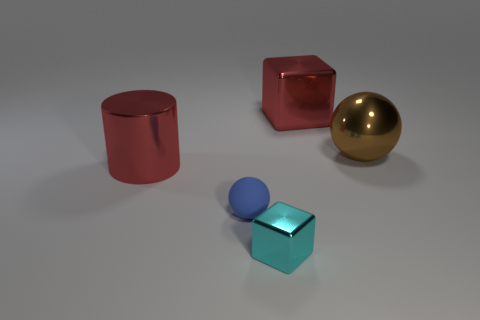Can you tell me what time of day it might be based on the lighting in the image? The lighting in the image seems artificial, as it is coming uniformly from above, suggesting that it is not related to the time of day but rather to the controlled lighting often used in studio photography or during the rendering of a 3D scene. 